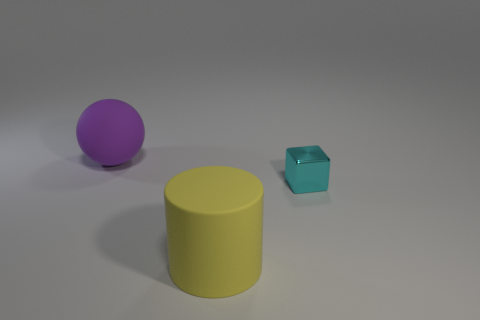Add 1 large purple rubber objects. How many objects exist? 4 Subtract all balls. How many objects are left? 2 Add 3 tiny red shiny things. How many tiny red shiny things exist? 3 Subtract 1 yellow cylinders. How many objects are left? 2 Subtract all brown blocks. Subtract all brown spheres. How many blocks are left? 1 Subtract all large blue matte objects. Subtract all cyan things. How many objects are left? 2 Add 2 yellow rubber objects. How many yellow rubber objects are left? 3 